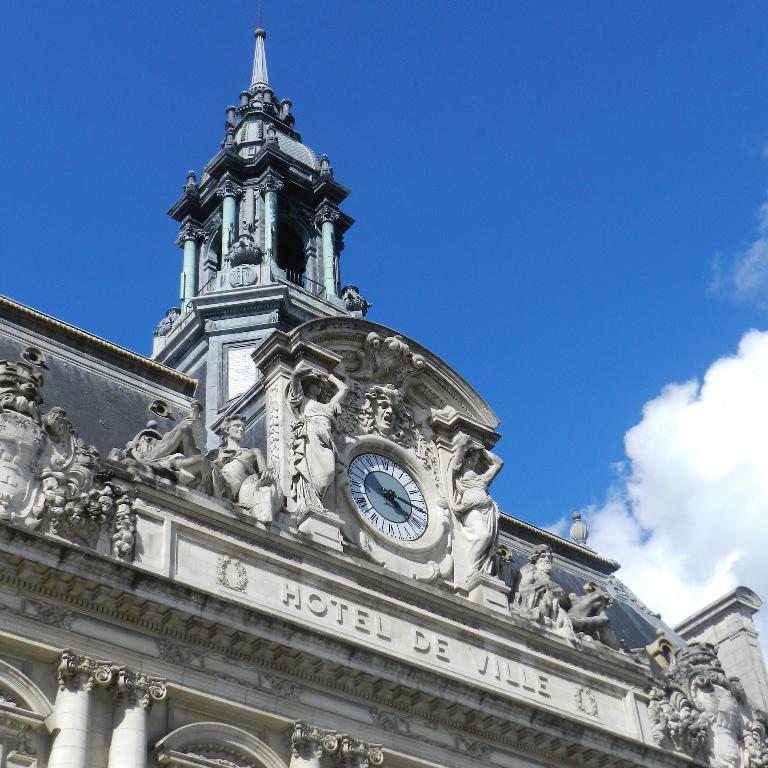What is the name of the hotel?
Offer a terse response. Hotel de ville. What time is on the clock?
Your answer should be compact. 4:15. 